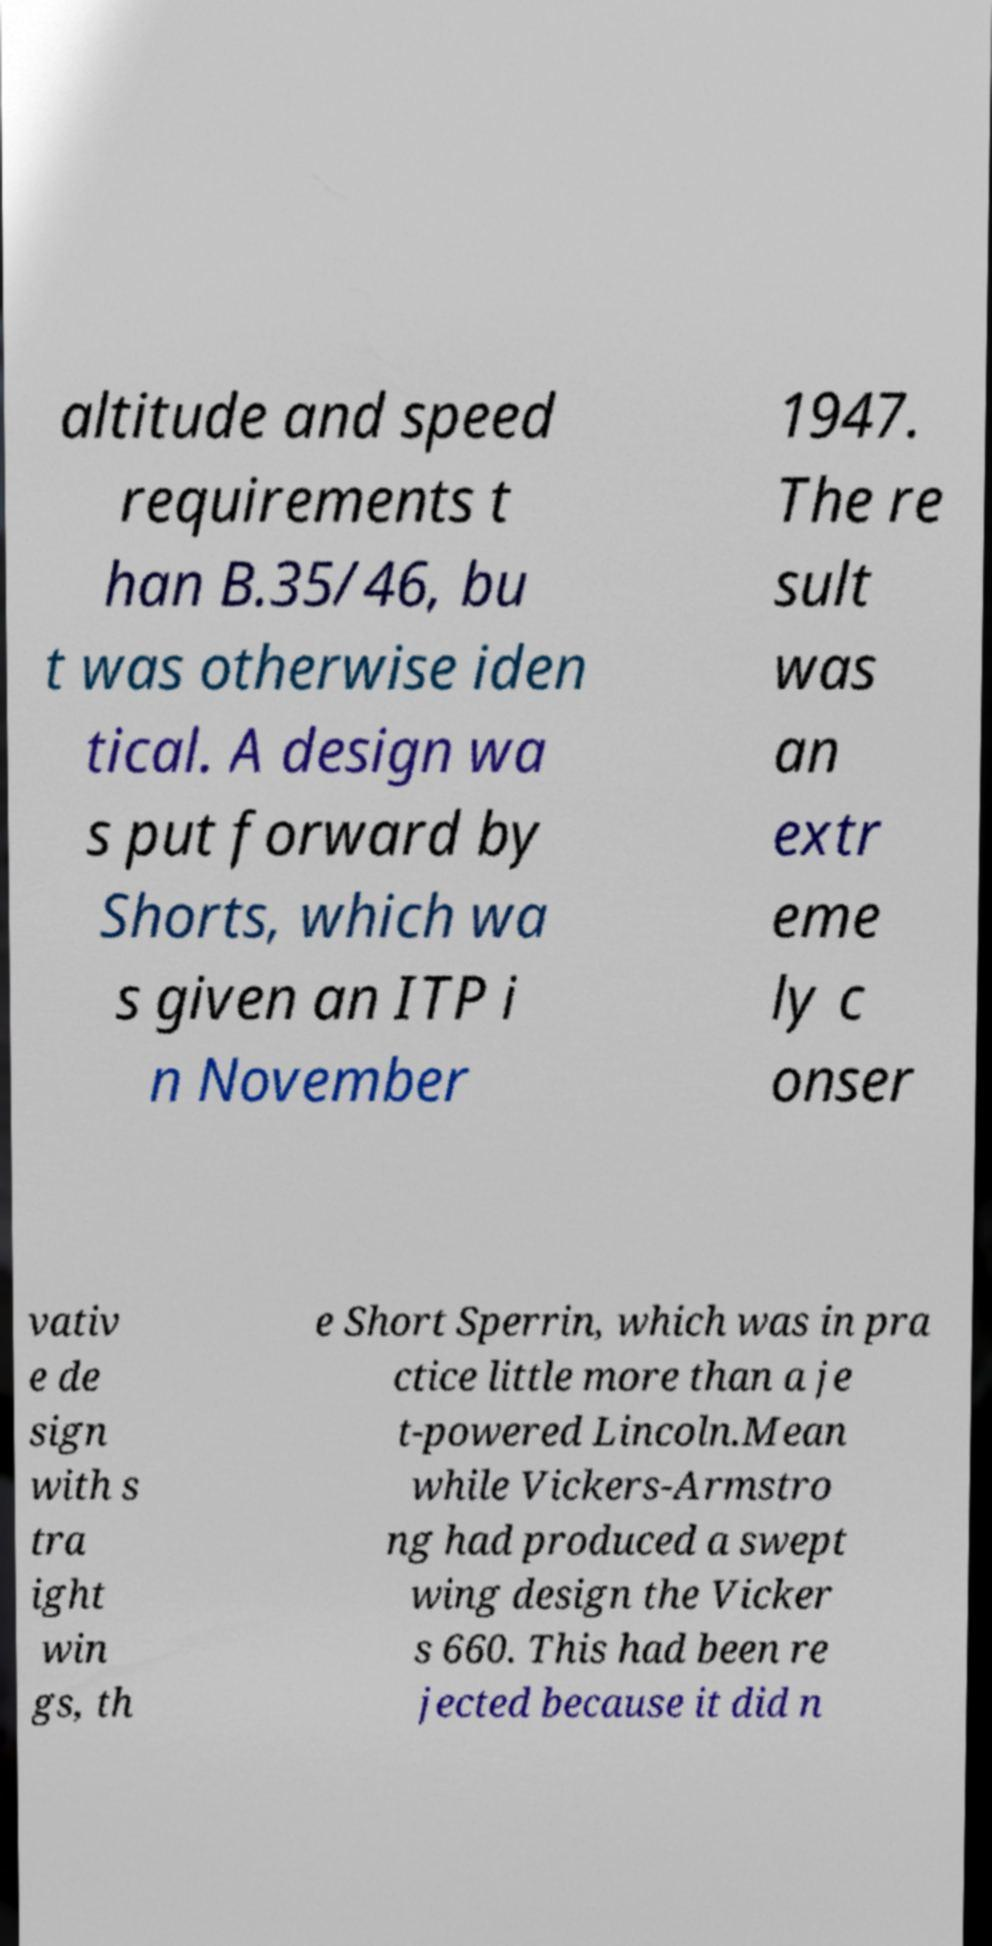I need the written content from this picture converted into text. Can you do that? altitude and speed requirements t han B.35/46, bu t was otherwise iden tical. A design wa s put forward by Shorts, which wa s given an ITP i n November 1947. The re sult was an extr eme ly c onser vativ e de sign with s tra ight win gs, th e Short Sperrin, which was in pra ctice little more than a je t-powered Lincoln.Mean while Vickers-Armstro ng had produced a swept wing design the Vicker s 660. This had been re jected because it did n 